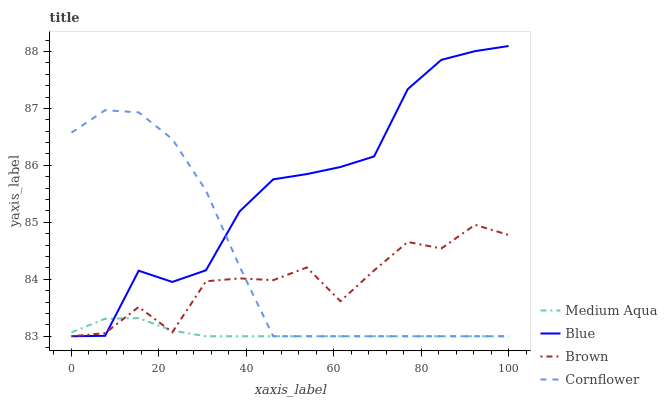Does Medium Aqua have the minimum area under the curve?
Answer yes or no. Yes. Does Blue have the maximum area under the curve?
Answer yes or no. Yes. Does Brown have the minimum area under the curve?
Answer yes or no. No. Does Brown have the maximum area under the curve?
Answer yes or no. No. Is Medium Aqua the smoothest?
Answer yes or no. Yes. Is Brown the roughest?
Answer yes or no. Yes. Is Brown the smoothest?
Answer yes or no. No. Is Medium Aqua the roughest?
Answer yes or no. No. Does Blue have the lowest value?
Answer yes or no. Yes. Does Blue have the highest value?
Answer yes or no. Yes. Does Brown have the highest value?
Answer yes or no. No. Does Cornflower intersect Blue?
Answer yes or no. Yes. Is Cornflower less than Blue?
Answer yes or no. No. Is Cornflower greater than Blue?
Answer yes or no. No. 